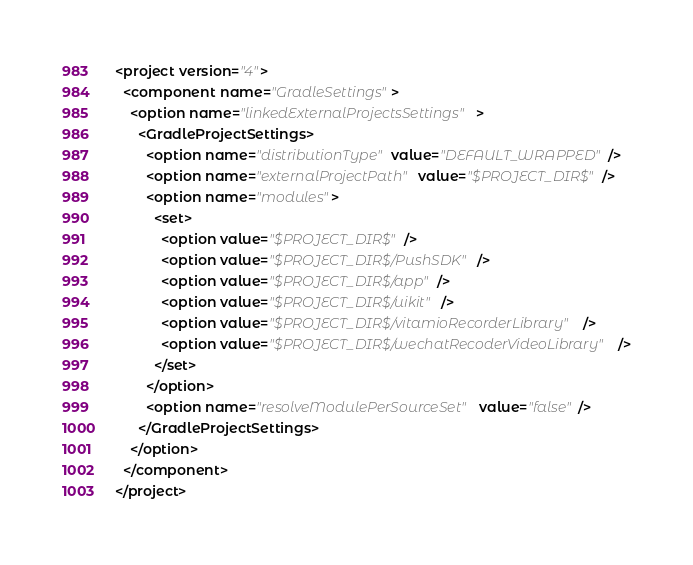Convert code to text. <code><loc_0><loc_0><loc_500><loc_500><_XML_><project version="4">
  <component name="GradleSettings">
    <option name="linkedExternalProjectsSettings">
      <GradleProjectSettings>
        <option name="distributionType" value="DEFAULT_WRAPPED" />
        <option name="externalProjectPath" value="$PROJECT_DIR$" />
        <option name="modules">
          <set>
            <option value="$PROJECT_DIR$" />
            <option value="$PROJECT_DIR$/PushSDK" />
            <option value="$PROJECT_DIR$/app" />
            <option value="$PROJECT_DIR$/uikit" />
            <option value="$PROJECT_DIR$/vitamioRecorderLibrary" />
            <option value="$PROJECT_DIR$/wechatRecoderVideoLibrary" />
          </set>
        </option>
        <option name="resolveModulePerSourceSet" value="false" />
      </GradleProjectSettings>
    </option>
  </component>
</project></code> 